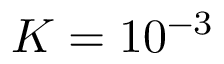Convert formula to latex. <formula><loc_0><loc_0><loc_500><loc_500>K = 1 0 ^ { - 3 }</formula> 